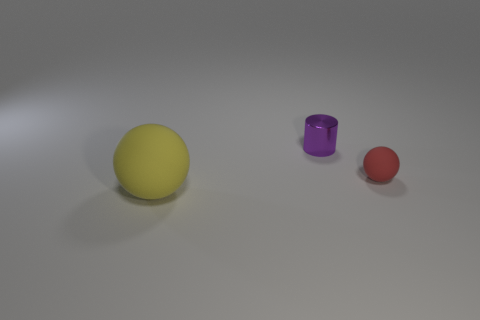Add 3 tiny objects. How many objects exist? 6 Subtract all cylinders. How many objects are left? 2 Subtract 0 gray cylinders. How many objects are left? 3 Subtract all cyan matte cubes. Subtract all large yellow spheres. How many objects are left? 2 Add 2 small metal things. How many small metal things are left? 3 Add 1 yellow objects. How many yellow objects exist? 2 